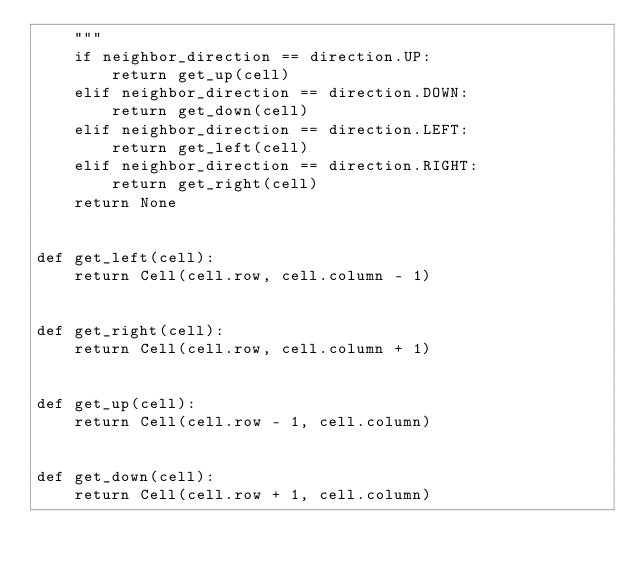Convert code to text. <code><loc_0><loc_0><loc_500><loc_500><_Python_>    """
    if neighbor_direction == direction.UP:
        return get_up(cell)
    elif neighbor_direction == direction.DOWN:
        return get_down(cell)
    elif neighbor_direction == direction.LEFT:
        return get_left(cell)
    elif neighbor_direction == direction.RIGHT:
        return get_right(cell)
    return None


def get_left(cell):
    return Cell(cell.row, cell.column - 1)


def get_right(cell):
    return Cell(cell.row, cell.column + 1)


def get_up(cell):
    return Cell(cell.row - 1, cell.column)


def get_down(cell):
    return Cell(cell.row + 1, cell.column)
</code> 